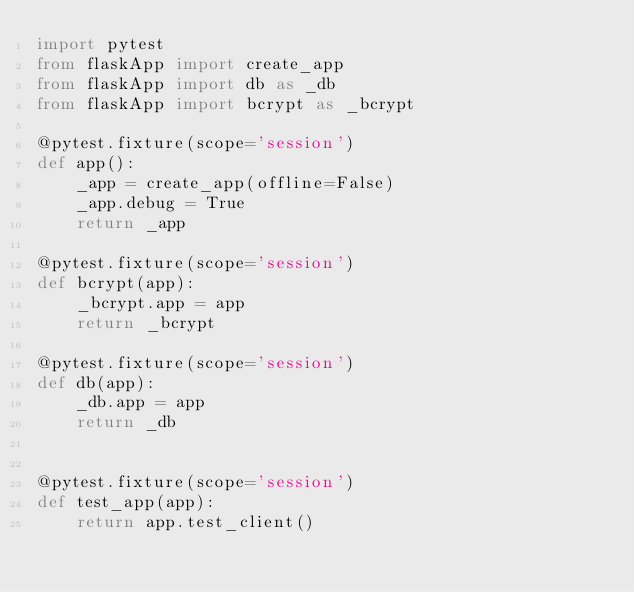Convert code to text. <code><loc_0><loc_0><loc_500><loc_500><_Python_>import pytest
from flaskApp import create_app
from flaskApp import db as _db
from flaskApp import bcrypt as _bcrypt

@pytest.fixture(scope='session')
def app():
    _app = create_app(offline=False)
    _app.debug = True
    return _app

@pytest.fixture(scope='session')
def bcrypt(app):
    _bcrypt.app = app
    return _bcrypt

@pytest.fixture(scope='session')
def db(app):
    _db.app = app
    return _db


@pytest.fixture(scope='session')
def test_app(app):
    return app.test_client()
</code> 